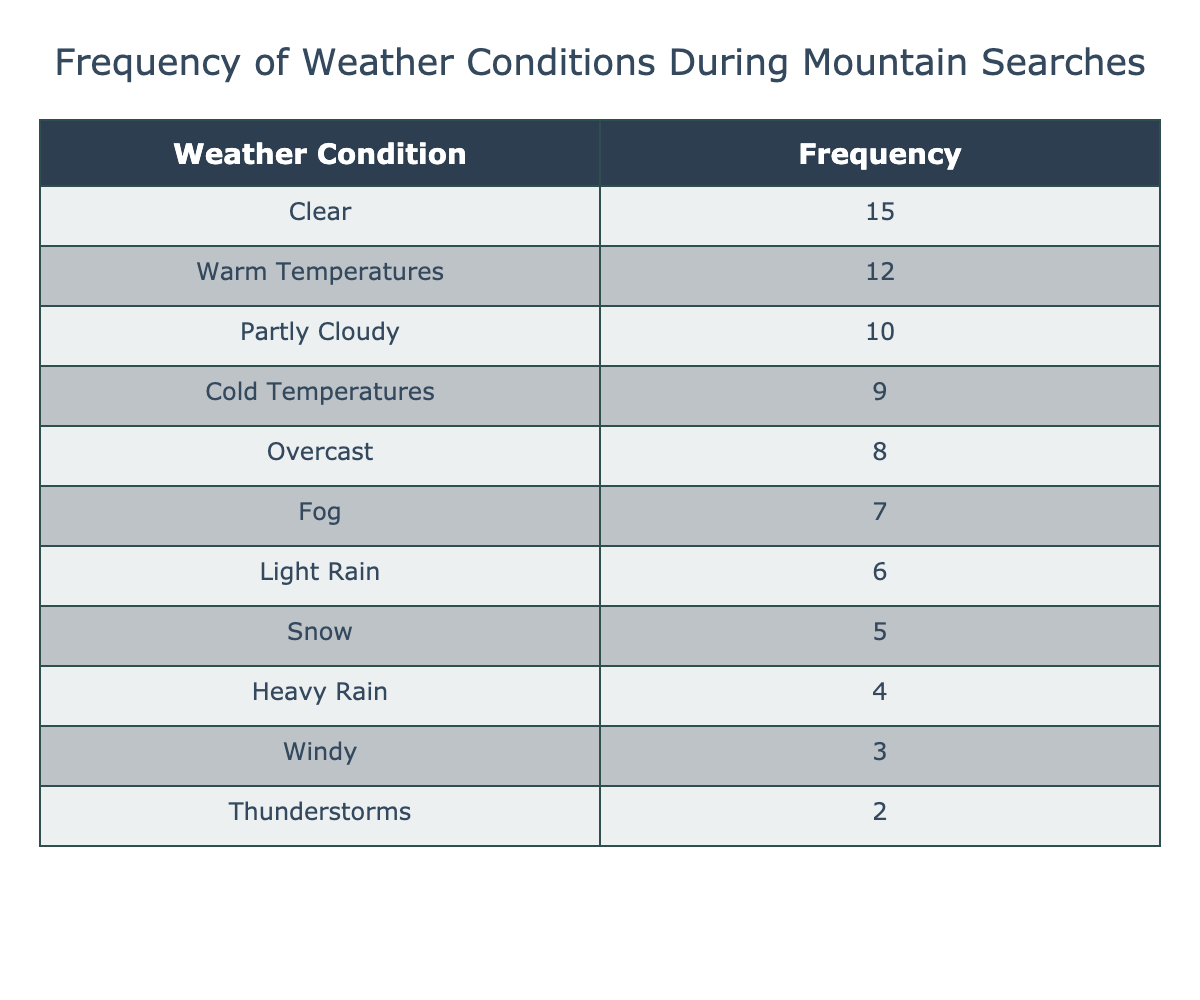What is the most frequent weather condition during mountain searches? The table lists the weather conditions and their frequencies. The highest frequency is 15, which corresponds to the "Clear" weather condition.
Answer: Clear How many weather conditions have a frequency of 6 or more? The table shows the frequencies for each weather condition. Counting those with frequency 6 or higher: Clear (15), Partly Cloudy (10), Warm Temperatures (12), Overcast (8), Fog (7), Light Rain (6), and Snow (5) does not count. Thus, there are 6 weather conditions that fulfill this criterion.
Answer: 6 Are there more weather conditions with frequencies below 5 or 10? The weather conditions with frequencies below 5 are Heavy Rain (4) and Thunderstorms (2), making a total of 2. The weather conditions with frequencies below 10 are Light Rain, Heavy Rain, Snow, Fog, Windy, and Thunderstorms, totaling 6. Therefore, there are more conditions below 10.
Answer: No What is the total frequency of weather conditions that are characterized as "Rain"? The weather conditions that imply rain are Light Rain (6) and Heavy Rain (4). Adding these frequencies gives us 6 + 4 = 10.
Answer: 10 Which weather condition has the least frequency? Looking at the frequencies, Windy has a frequency of 3, which is the lowest among all the listed weather conditions.
Answer: Windy What is the difference in frequency between the "Clear" condition and the "Thunderstorms" condition? The frequency of "Clear" is 15, and the frequency of "Thunderstorms" is 2. The difference is calculated as 15 - 2 = 13.
Answer: 13 What is the average frequency of the weather conditions classified as "Cold Temperatures" or "Snow"? The frequencies for "Cold Temperatures" and "Snow" are 9 and 5, respectively. We can find the average by adding them (9 + 5 = 14) and dividing by the number of conditions (2). Therefore, the average is 14 / 2 = 7.
Answer: 7 How many weather conditions are associated with "Cloudy" weather? The conditions that could be associated with cloudy weather are Partly Cloudy (10), Overcast (8), and Fog (7). Thus, there are a total of 3 conditions related to cloudy weather.
Answer: 3 